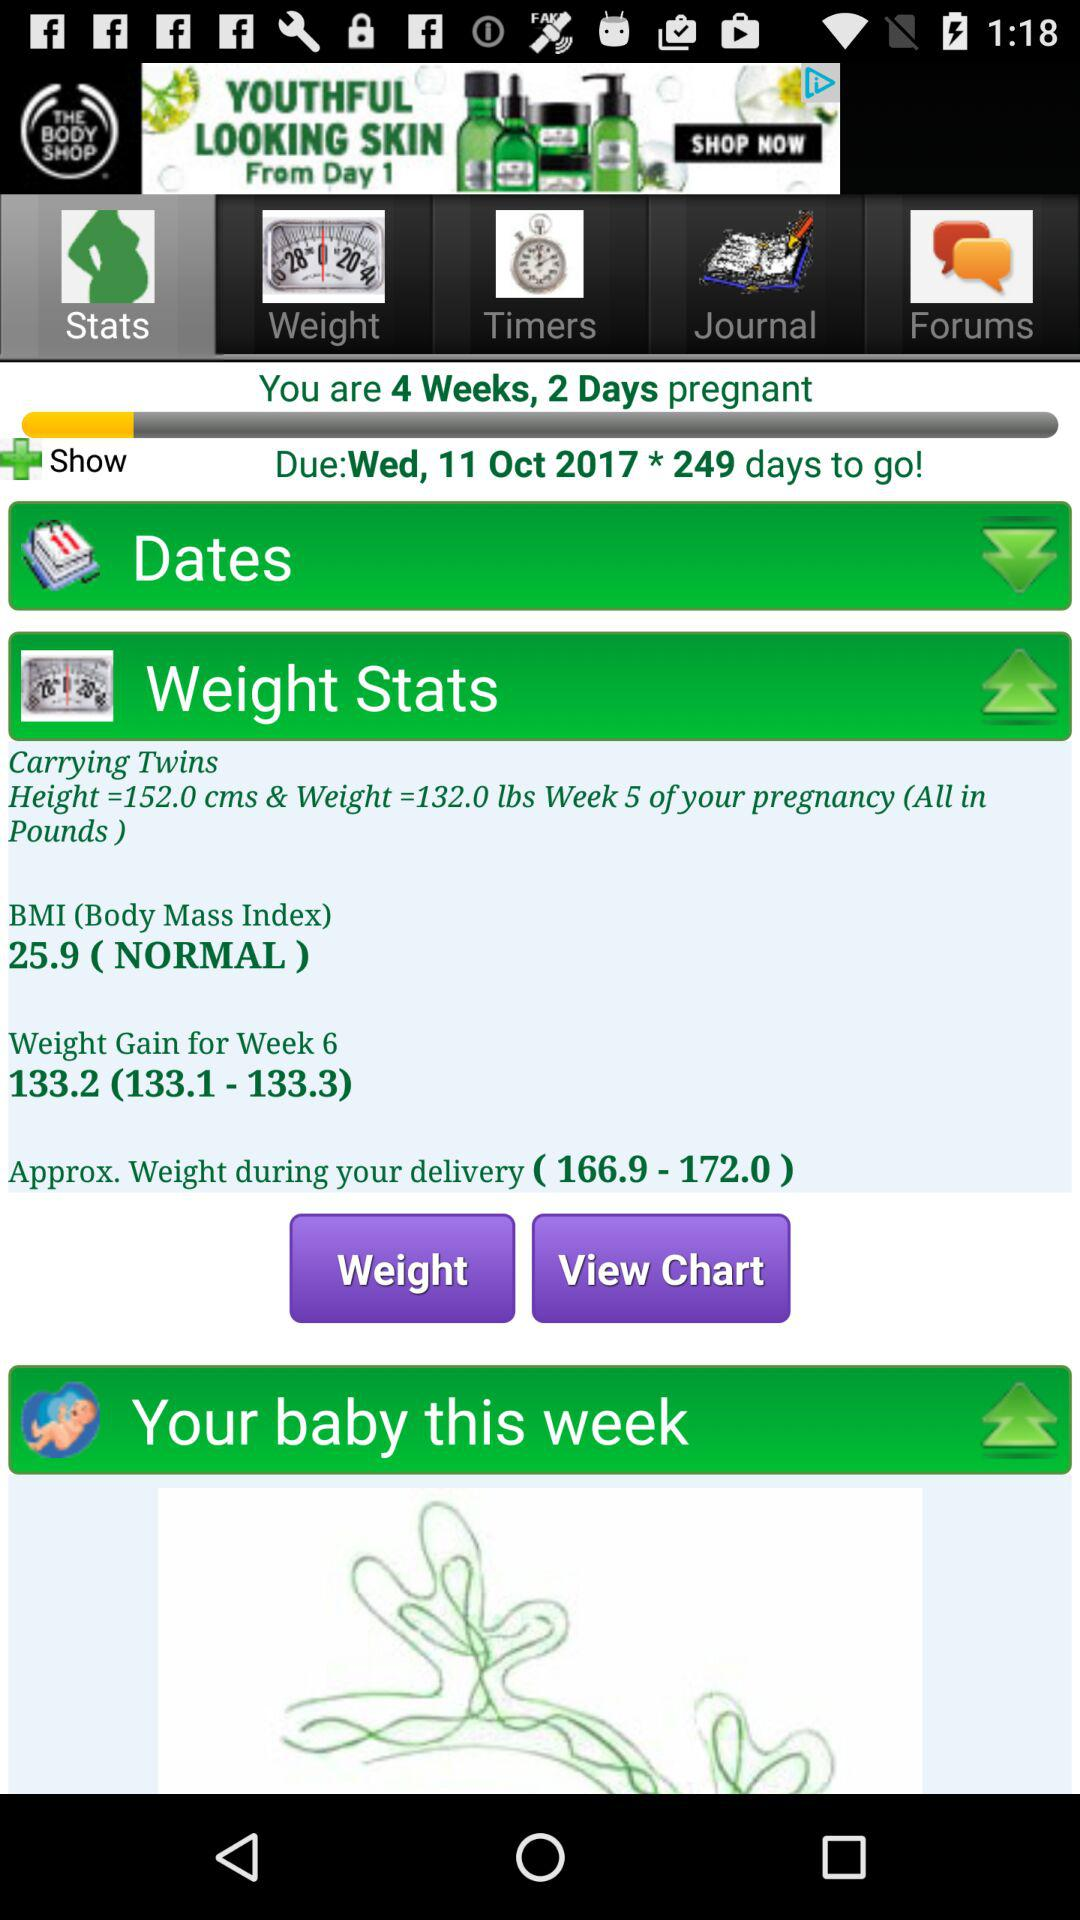What is the due date? The due date is Wednesday, October 11, 2017. 